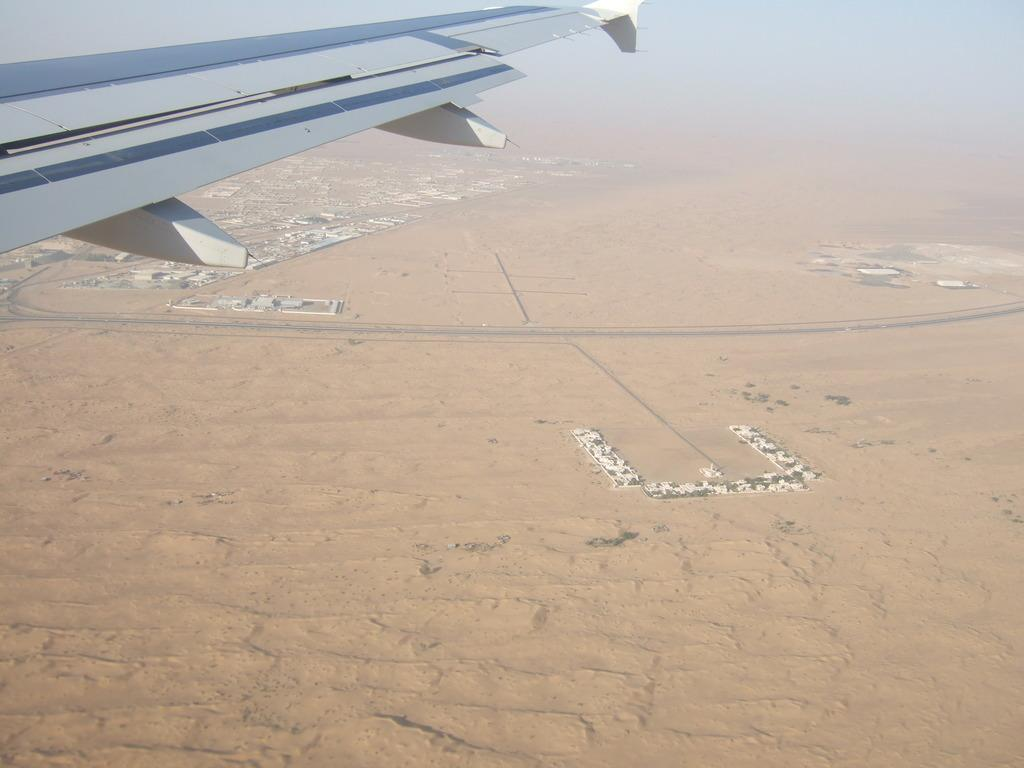What is the perspective of the image? The image is captured from a plane. What type of landscape can be seen in the image? There is an empty land visible in the image. What natural elements are present in the image? There are trees in the image. What man-made structures can be seen in the image? There are houses in the image. What type of shoes can be seen hanging from the trees in the image? There are no shoes present in the image; it only features an empty land, trees, and houses. 